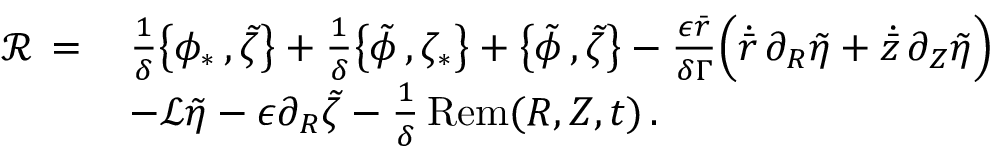Convert formula to latex. <formula><loc_0><loc_0><loc_500><loc_500>\begin{array} { r l } { \mathcal { R } \, = \, } & { \frac { 1 } { \delta } \left \{ \phi _ { * } \, , \tilde { \zeta } \right \} + \frac { 1 } { \delta } \left \{ \tilde { \phi } \, , \zeta _ { * } \right \} + \left \{ \tilde { \phi } \, , \tilde { \zeta } \right \} - \frac { \epsilon \bar { r } } { \delta \Gamma } \left ( \dot { \bar { r } } \, \partial _ { R } \tilde { \eta } + \dot { \bar { z } } \, \partial _ { Z } \tilde { \eta } \right ) } \\ & { - \mathcal { L } \tilde { \eta } - \epsilon \partial _ { R } \tilde { \zeta } - \frac { 1 } { \delta } \, R e m ( R , Z , t ) \, . } \end{array}</formula> 